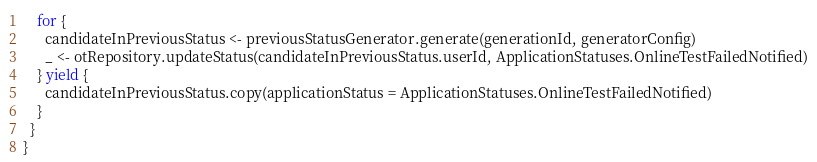<code> <loc_0><loc_0><loc_500><loc_500><_Scala_>
    for {
      candidateInPreviousStatus <- previousStatusGenerator.generate(generationId, generatorConfig)
      _ <- otRepository.updateStatus(candidateInPreviousStatus.userId, ApplicationStatuses.OnlineTestFailedNotified)
    } yield {
      candidateInPreviousStatus.copy(applicationStatus = ApplicationStatuses.OnlineTestFailedNotified)
    }
  }
}
</code> 